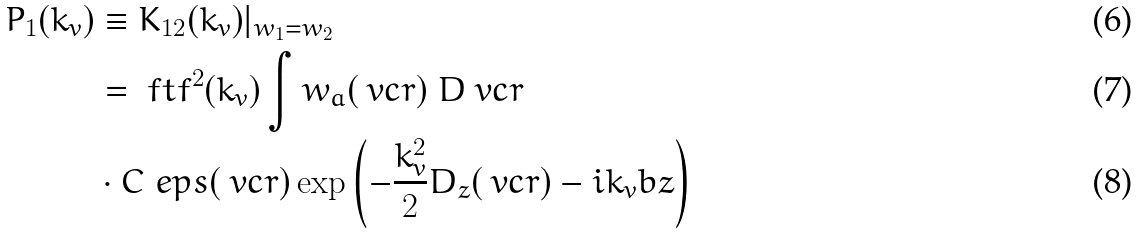<formula> <loc_0><loc_0><loc_500><loc_500>P _ { 1 } ( k _ { v } ) & \equiv K _ { 1 2 } ( k _ { v } ) | _ { w _ { 1 } = w _ { 2 } } \\ & = \ f t { f } ^ { 2 } ( k _ { v } ) \int w _ { a } ( \ v c { r } ) \ D { \ v c { r } } \\ & \cdot C _ { \ } e p s ( \ v c { r } ) \exp \left ( - \frac { k _ { v } ^ { 2 } } { 2 } D _ { z } ( \ v c { r } ) - i k _ { v } b z \right )</formula> 